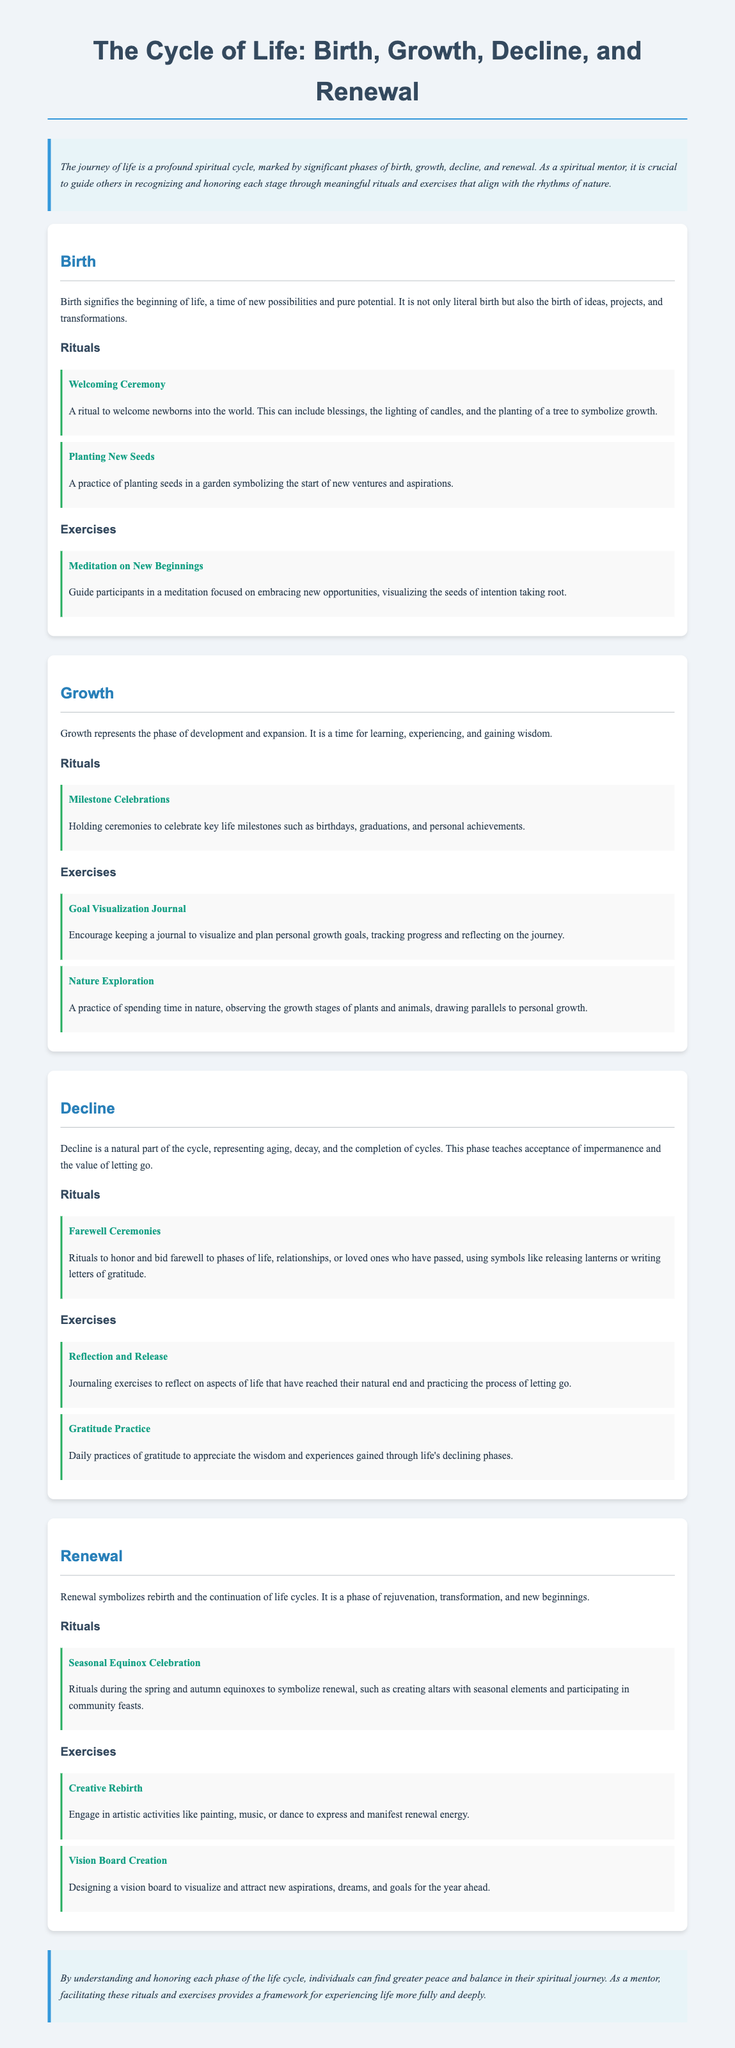what are the four phases of the life cycle? The document outlines the four phases of the life cycle as Birth, Growth, Decline, and Renewal.
Answer: Birth, Growth, Decline, Renewal what is a ritual associated with Birth? A welcoming ceremony is mentioned as a ritual to welcome newborns into the world.
Answer: Welcoming Ceremony how does the Growth phase signify a key aspect of life? Growth is characterized as a phase for learning, experiencing, and gaining wisdom.
Answer: Learning, experiencing, gaining wisdom what exercise helps with visualizing personal growth? The Goal Visualization Journal is an exercise that encourages planning personal growth goals.
Answer: Goal Visualization Journal what type of ritual is performed during the Renewal phase? Seasonal Equinox Celebration is a ritual that symbolizes renewal.
Answer: Seasonal Equinox Celebration what is a practice during the Decline phase? The Reflection and Release is an exercise during the Decline phase that involves journaling.
Answer: Reflection and Release how does the document describe the Renewal phase? The Renewal phase is described as a phase of rejuvenation, transformation, and new beginnings.
Answer: Rejuvenation, transformation, new beginnings what is included in the introduction of the document? The introduction discusses the importance of recognizing and honoring each life stage through rituals and exercises.
Answer: Recognizing and honoring life stages what kind of exercise is used to express renewal energy? The Creative Rebirth engages artistic activities to express renewal energy.
Answer: Creative Rebirth 